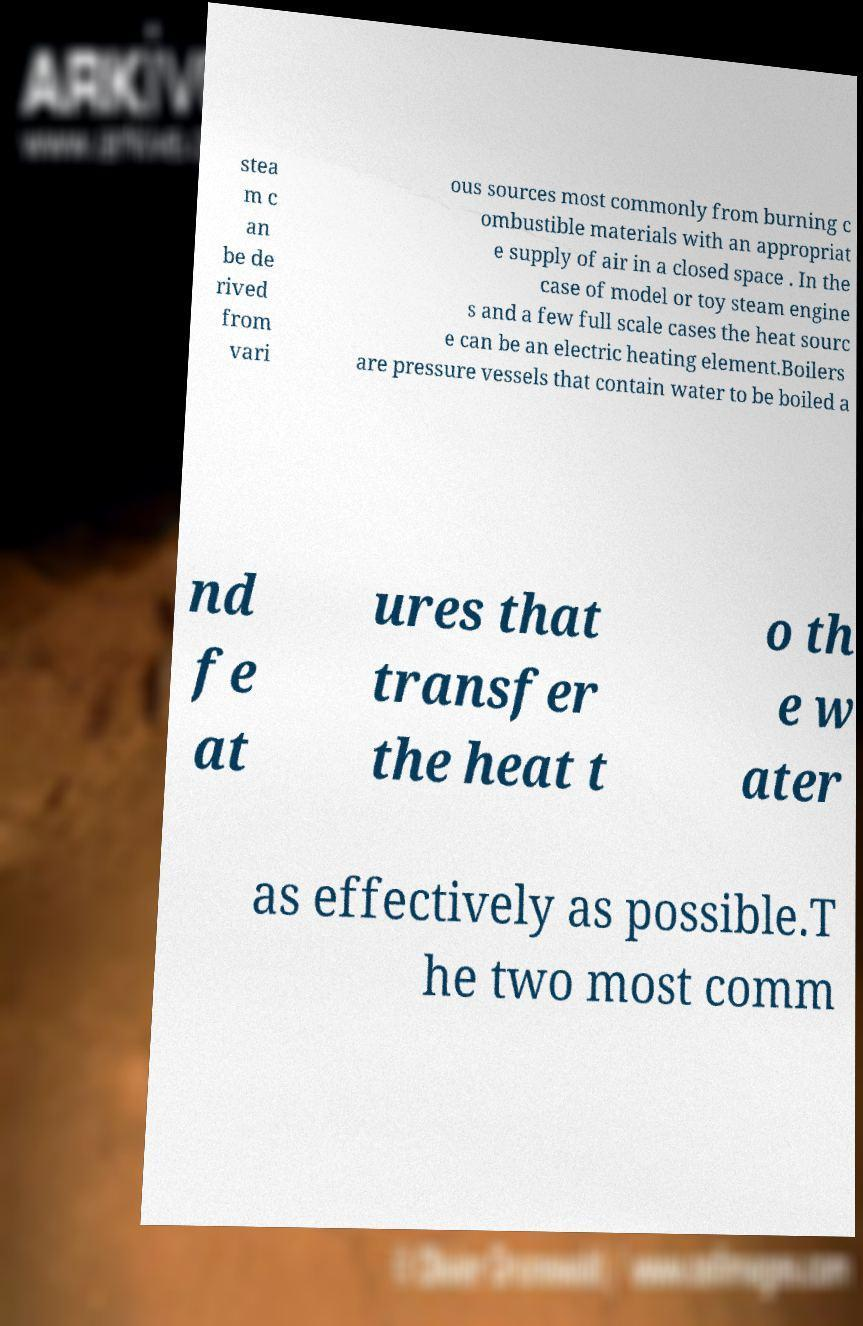For documentation purposes, I need the text within this image transcribed. Could you provide that? stea m c an be de rived from vari ous sources most commonly from burning c ombustible materials with an appropriat e supply of air in a closed space . In the case of model or toy steam engine s and a few full scale cases the heat sourc e can be an electric heating element.Boilers are pressure vessels that contain water to be boiled a nd fe at ures that transfer the heat t o th e w ater as effectively as possible.T he two most comm 